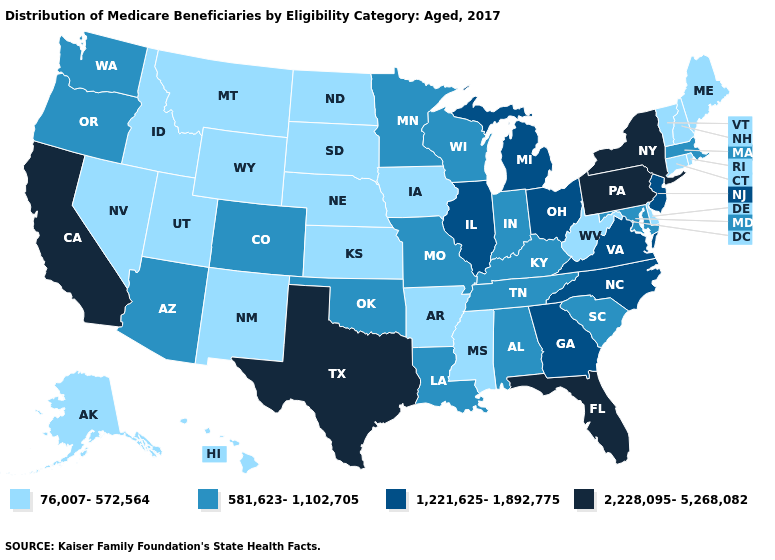What is the value of Tennessee?
Short answer required. 581,623-1,102,705. Name the states that have a value in the range 76,007-572,564?
Keep it brief. Alaska, Arkansas, Connecticut, Delaware, Hawaii, Idaho, Iowa, Kansas, Maine, Mississippi, Montana, Nebraska, Nevada, New Hampshire, New Mexico, North Dakota, Rhode Island, South Dakota, Utah, Vermont, West Virginia, Wyoming. Name the states that have a value in the range 1,221,625-1,892,775?
Quick response, please. Georgia, Illinois, Michigan, New Jersey, North Carolina, Ohio, Virginia. What is the value of New Mexico?
Write a very short answer. 76,007-572,564. Name the states that have a value in the range 76,007-572,564?
Answer briefly. Alaska, Arkansas, Connecticut, Delaware, Hawaii, Idaho, Iowa, Kansas, Maine, Mississippi, Montana, Nebraska, Nevada, New Hampshire, New Mexico, North Dakota, Rhode Island, South Dakota, Utah, Vermont, West Virginia, Wyoming. Does Mississippi have the same value as Nebraska?
Keep it brief. Yes. Name the states that have a value in the range 2,228,095-5,268,082?
Keep it brief. California, Florida, New York, Pennsylvania, Texas. What is the value of Kansas?
Quick response, please. 76,007-572,564. Does South Dakota have the highest value in the MidWest?
Give a very brief answer. No. What is the lowest value in the USA?
Be succinct. 76,007-572,564. Among the states that border Massachusetts , does Vermont have the lowest value?
Answer briefly. Yes. What is the value of New Jersey?
Quick response, please. 1,221,625-1,892,775. What is the value of Oregon?
Be succinct. 581,623-1,102,705. What is the value of Washington?
Short answer required. 581,623-1,102,705. 